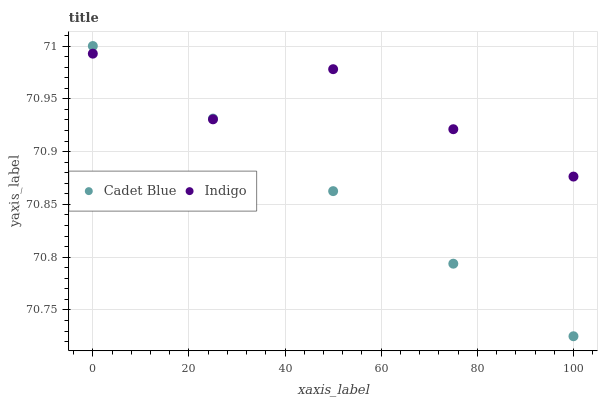Does Cadet Blue have the minimum area under the curve?
Answer yes or no. Yes. Does Indigo have the maximum area under the curve?
Answer yes or no. Yes. Does Indigo have the minimum area under the curve?
Answer yes or no. No. Is Cadet Blue the smoothest?
Answer yes or no. Yes. Is Indigo the roughest?
Answer yes or no. Yes. Is Indigo the smoothest?
Answer yes or no. No. Does Cadet Blue have the lowest value?
Answer yes or no. Yes. Does Indigo have the lowest value?
Answer yes or no. No. Does Cadet Blue have the highest value?
Answer yes or no. Yes. Does Indigo have the highest value?
Answer yes or no. No. Does Cadet Blue intersect Indigo?
Answer yes or no. Yes. Is Cadet Blue less than Indigo?
Answer yes or no. No. Is Cadet Blue greater than Indigo?
Answer yes or no. No. 